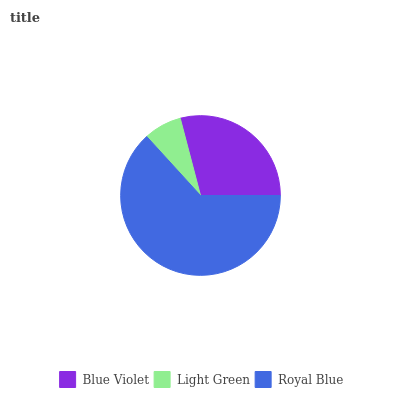Is Light Green the minimum?
Answer yes or no. Yes. Is Royal Blue the maximum?
Answer yes or no. Yes. Is Royal Blue the minimum?
Answer yes or no. No. Is Light Green the maximum?
Answer yes or no. No. Is Royal Blue greater than Light Green?
Answer yes or no. Yes. Is Light Green less than Royal Blue?
Answer yes or no. Yes. Is Light Green greater than Royal Blue?
Answer yes or no. No. Is Royal Blue less than Light Green?
Answer yes or no. No. Is Blue Violet the high median?
Answer yes or no. Yes. Is Blue Violet the low median?
Answer yes or no. Yes. Is Royal Blue the high median?
Answer yes or no. No. Is Light Green the low median?
Answer yes or no. No. 